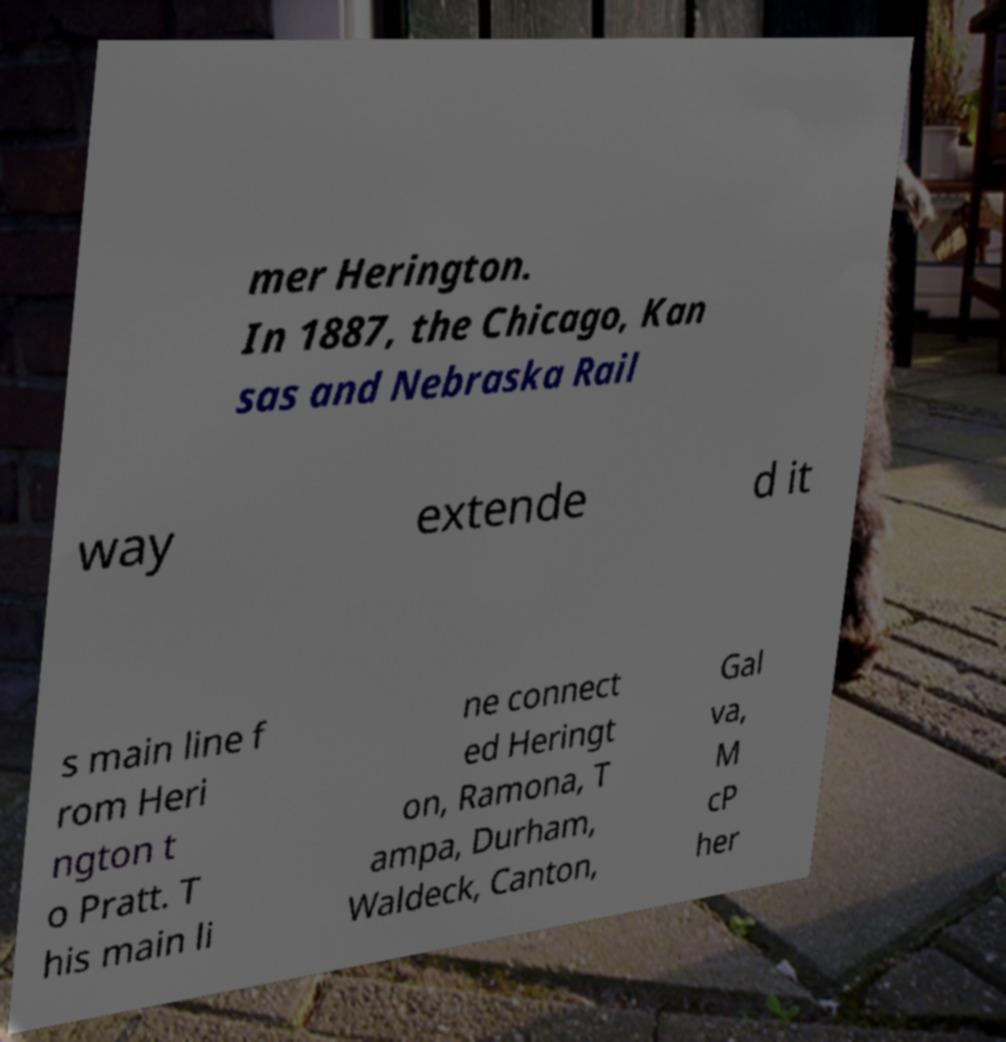There's text embedded in this image that I need extracted. Can you transcribe it verbatim? mer Herington. In 1887, the Chicago, Kan sas and Nebraska Rail way extende d it s main line f rom Heri ngton t o Pratt. T his main li ne connect ed Heringt on, Ramona, T ampa, Durham, Waldeck, Canton, Gal va, M cP her 